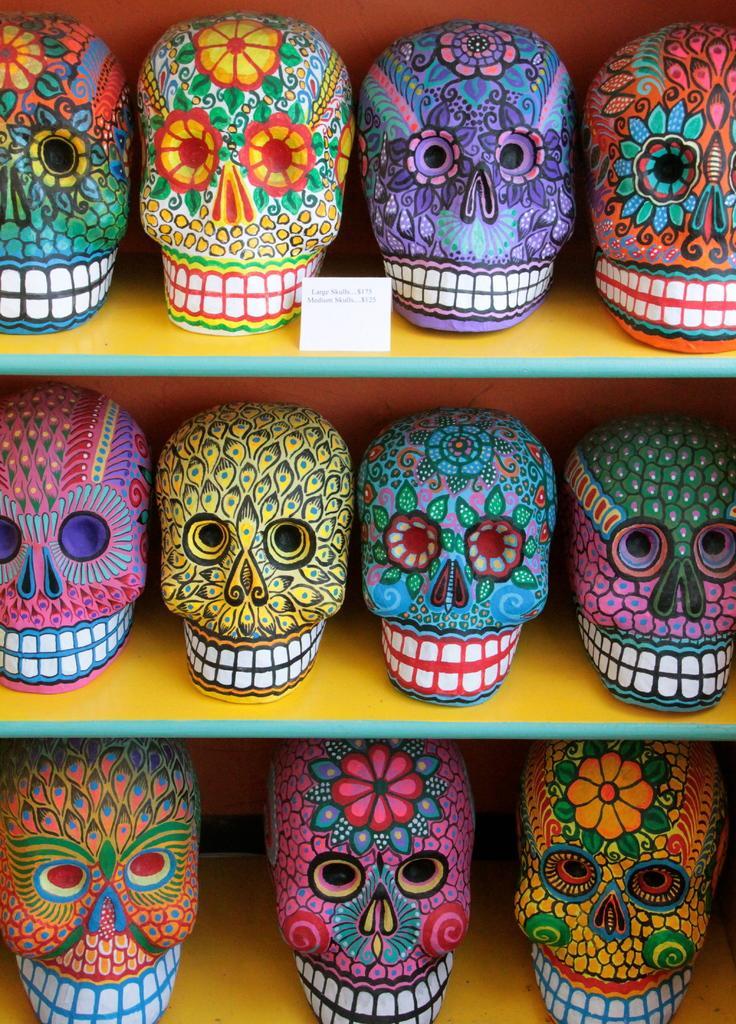In one or two sentences, can you explain what this image depicts? In this image there are many skull toys arranged in a shelf. 